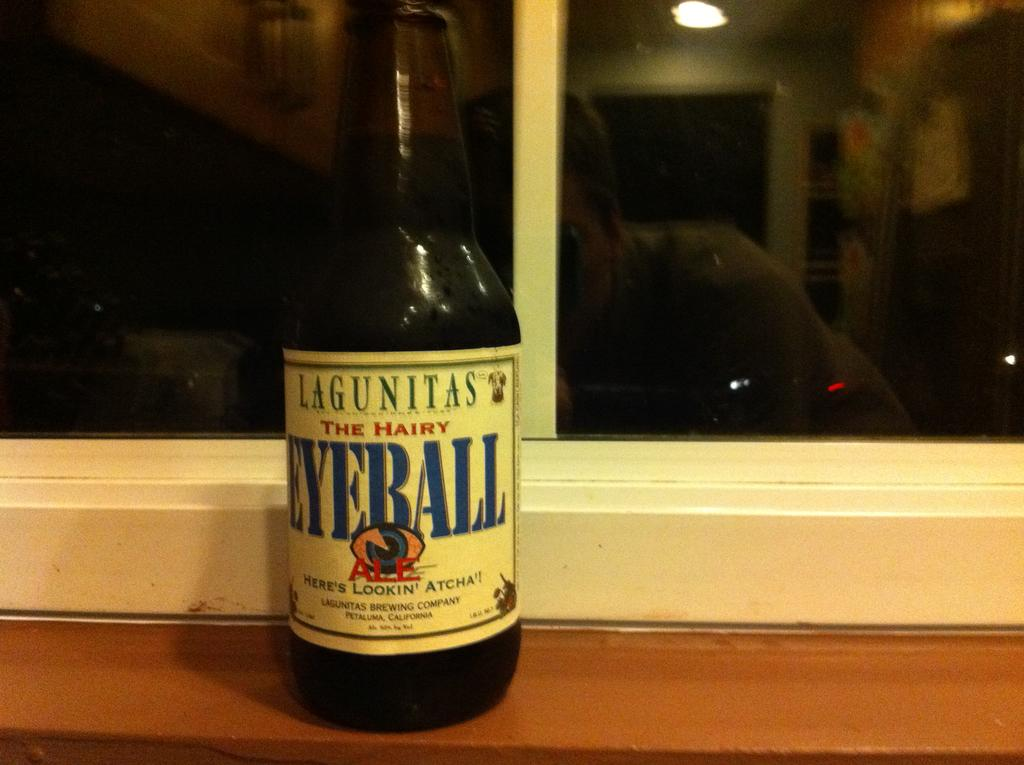Provide a one-sentence caption for the provided image. A bottle of The Hairy Eyeball sitting on the window seal. 